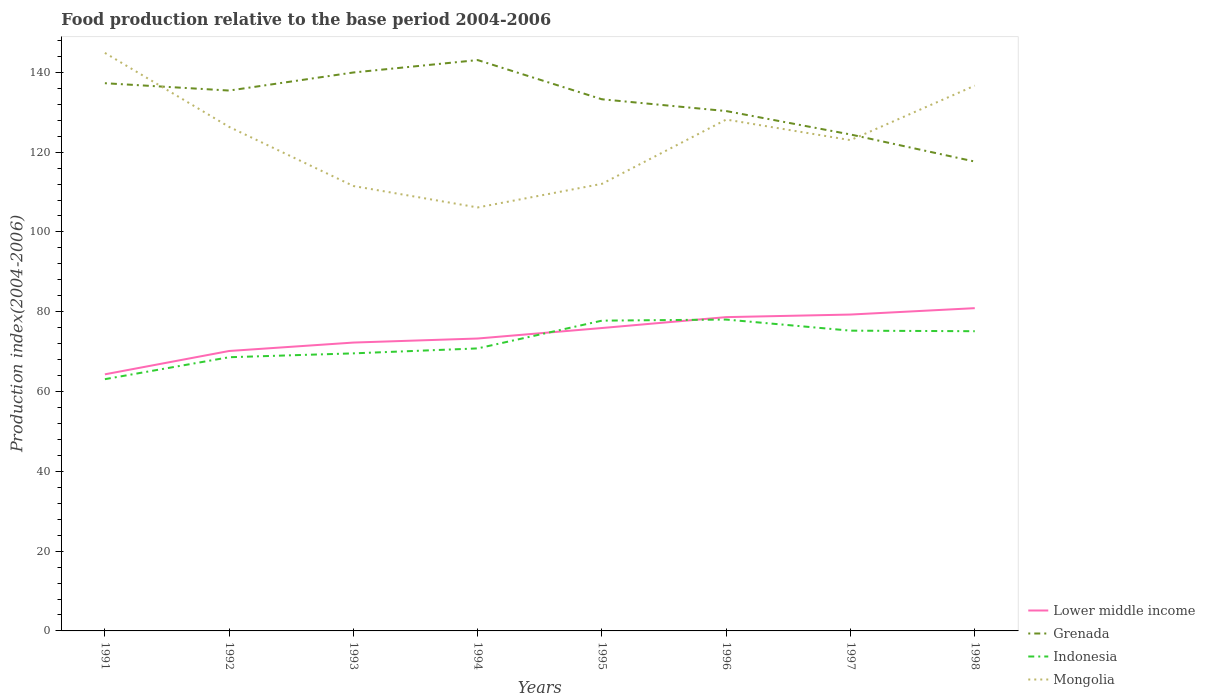Does the line corresponding to Grenada intersect with the line corresponding to Lower middle income?
Offer a terse response. No. Across all years, what is the maximum food production index in Grenada?
Offer a terse response. 117.64. In which year was the food production index in Mongolia maximum?
Offer a terse response. 1994. What is the total food production index in Indonesia in the graph?
Offer a very short reply. -12.16. What is the difference between the highest and the second highest food production index in Grenada?
Provide a succinct answer. 25.44. How many lines are there?
Keep it short and to the point. 4. How many years are there in the graph?
Your answer should be compact. 8. Are the values on the major ticks of Y-axis written in scientific E-notation?
Keep it short and to the point. No. Does the graph contain any zero values?
Provide a succinct answer. No. Does the graph contain grids?
Provide a succinct answer. No. How many legend labels are there?
Ensure brevity in your answer.  4. How are the legend labels stacked?
Offer a terse response. Vertical. What is the title of the graph?
Offer a terse response. Food production relative to the base period 2004-2006. Does "Lithuania" appear as one of the legend labels in the graph?
Offer a terse response. No. What is the label or title of the X-axis?
Provide a short and direct response. Years. What is the label or title of the Y-axis?
Your answer should be very brief. Production index(2004-2006). What is the Production index(2004-2006) of Lower middle income in 1991?
Give a very brief answer. 64.31. What is the Production index(2004-2006) in Grenada in 1991?
Provide a succinct answer. 137.28. What is the Production index(2004-2006) in Indonesia in 1991?
Ensure brevity in your answer.  63.1. What is the Production index(2004-2006) of Mongolia in 1991?
Make the answer very short. 144.88. What is the Production index(2004-2006) in Lower middle income in 1992?
Make the answer very short. 70.16. What is the Production index(2004-2006) in Grenada in 1992?
Make the answer very short. 135.44. What is the Production index(2004-2006) of Indonesia in 1992?
Give a very brief answer. 68.6. What is the Production index(2004-2006) in Mongolia in 1992?
Your answer should be compact. 126.33. What is the Production index(2004-2006) in Lower middle income in 1993?
Provide a short and direct response. 72.27. What is the Production index(2004-2006) of Grenada in 1993?
Your answer should be compact. 139.97. What is the Production index(2004-2006) in Indonesia in 1993?
Give a very brief answer. 69.57. What is the Production index(2004-2006) in Mongolia in 1993?
Keep it short and to the point. 111.51. What is the Production index(2004-2006) in Lower middle income in 1994?
Keep it short and to the point. 73.29. What is the Production index(2004-2006) in Grenada in 1994?
Your answer should be very brief. 143.08. What is the Production index(2004-2006) of Indonesia in 1994?
Offer a terse response. 70.81. What is the Production index(2004-2006) in Mongolia in 1994?
Provide a succinct answer. 106.14. What is the Production index(2004-2006) in Lower middle income in 1995?
Your response must be concise. 75.92. What is the Production index(2004-2006) in Grenada in 1995?
Give a very brief answer. 133.25. What is the Production index(2004-2006) in Indonesia in 1995?
Your answer should be very brief. 77.77. What is the Production index(2004-2006) of Mongolia in 1995?
Make the answer very short. 112.06. What is the Production index(2004-2006) of Lower middle income in 1996?
Offer a very short reply. 78.65. What is the Production index(2004-2006) of Grenada in 1996?
Provide a succinct answer. 130.3. What is the Production index(2004-2006) of Indonesia in 1996?
Your response must be concise. 78.04. What is the Production index(2004-2006) of Mongolia in 1996?
Your answer should be very brief. 128.17. What is the Production index(2004-2006) of Lower middle income in 1997?
Give a very brief answer. 79.3. What is the Production index(2004-2006) in Grenada in 1997?
Give a very brief answer. 124.43. What is the Production index(2004-2006) of Indonesia in 1997?
Your response must be concise. 75.26. What is the Production index(2004-2006) of Mongolia in 1997?
Offer a terse response. 123.01. What is the Production index(2004-2006) of Lower middle income in 1998?
Keep it short and to the point. 80.9. What is the Production index(2004-2006) of Grenada in 1998?
Make the answer very short. 117.64. What is the Production index(2004-2006) in Indonesia in 1998?
Give a very brief answer. 75.12. What is the Production index(2004-2006) of Mongolia in 1998?
Your response must be concise. 136.67. Across all years, what is the maximum Production index(2004-2006) of Lower middle income?
Give a very brief answer. 80.9. Across all years, what is the maximum Production index(2004-2006) in Grenada?
Keep it short and to the point. 143.08. Across all years, what is the maximum Production index(2004-2006) of Indonesia?
Offer a very short reply. 78.04. Across all years, what is the maximum Production index(2004-2006) in Mongolia?
Provide a short and direct response. 144.88. Across all years, what is the minimum Production index(2004-2006) of Lower middle income?
Give a very brief answer. 64.31. Across all years, what is the minimum Production index(2004-2006) in Grenada?
Your answer should be compact. 117.64. Across all years, what is the minimum Production index(2004-2006) of Indonesia?
Make the answer very short. 63.1. Across all years, what is the minimum Production index(2004-2006) in Mongolia?
Your answer should be compact. 106.14. What is the total Production index(2004-2006) in Lower middle income in the graph?
Offer a terse response. 594.81. What is the total Production index(2004-2006) of Grenada in the graph?
Make the answer very short. 1061.39. What is the total Production index(2004-2006) in Indonesia in the graph?
Ensure brevity in your answer.  578.27. What is the total Production index(2004-2006) in Mongolia in the graph?
Your answer should be compact. 988.77. What is the difference between the Production index(2004-2006) in Lower middle income in 1991 and that in 1992?
Your answer should be very brief. -5.85. What is the difference between the Production index(2004-2006) of Grenada in 1991 and that in 1992?
Give a very brief answer. 1.84. What is the difference between the Production index(2004-2006) of Mongolia in 1991 and that in 1992?
Provide a succinct answer. 18.55. What is the difference between the Production index(2004-2006) of Lower middle income in 1991 and that in 1993?
Keep it short and to the point. -7.96. What is the difference between the Production index(2004-2006) of Grenada in 1991 and that in 1993?
Your answer should be compact. -2.69. What is the difference between the Production index(2004-2006) of Indonesia in 1991 and that in 1993?
Offer a terse response. -6.47. What is the difference between the Production index(2004-2006) in Mongolia in 1991 and that in 1993?
Offer a terse response. 33.37. What is the difference between the Production index(2004-2006) of Lower middle income in 1991 and that in 1994?
Provide a succinct answer. -8.98. What is the difference between the Production index(2004-2006) in Grenada in 1991 and that in 1994?
Offer a very short reply. -5.8. What is the difference between the Production index(2004-2006) in Indonesia in 1991 and that in 1994?
Give a very brief answer. -7.71. What is the difference between the Production index(2004-2006) of Mongolia in 1991 and that in 1994?
Make the answer very short. 38.74. What is the difference between the Production index(2004-2006) in Lower middle income in 1991 and that in 1995?
Provide a short and direct response. -11.61. What is the difference between the Production index(2004-2006) of Grenada in 1991 and that in 1995?
Offer a very short reply. 4.03. What is the difference between the Production index(2004-2006) of Indonesia in 1991 and that in 1995?
Make the answer very short. -14.67. What is the difference between the Production index(2004-2006) of Mongolia in 1991 and that in 1995?
Make the answer very short. 32.82. What is the difference between the Production index(2004-2006) in Lower middle income in 1991 and that in 1996?
Provide a succinct answer. -14.34. What is the difference between the Production index(2004-2006) of Grenada in 1991 and that in 1996?
Ensure brevity in your answer.  6.98. What is the difference between the Production index(2004-2006) in Indonesia in 1991 and that in 1996?
Ensure brevity in your answer.  -14.94. What is the difference between the Production index(2004-2006) in Mongolia in 1991 and that in 1996?
Make the answer very short. 16.71. What is the difference between the Production index(2004-2006) in Lower middle income in 1991 and that in 1997?
Offer a very short reply. -14.98. What is the difference between the Production index(2004-2006) in Grenada in 1991 and that in 1997?
Your answer should be very brief. 12.85. What is the difference between the Production index(2004-2006) of Indonesia in 1991 and that in 1997?
Your answer should be very brief. -12.16. What is the difference between the Production index(2004-2006) in Mongolia in 1991 and that in 1997?
Your response must be concise. 21.87. What is the difference between the Production index(2004-2006) in Lower middle income in 1991 and that in 1998?
Offer a terse response. -16.58. What is the difference between the Production index(2004-2006) in Grenada in 1991 and that in 1998?
Provide a short and direct response. 19.64. What is the difference between the Production index(2004-2006) in Indonesia in 1991 and that in 1998?
Offer a terse response. -12.02. What is the difference between the Production index(2004-2006) of Mongolia in 1991 and that in 1998?
Make the answer very short. 8.21. What is the difference between the Production index(2004-2006) of Lower middle income in 1992 and that in 1993?
Ensure brevity in your answer.  -2.11. What is the difference between the Production index(2004-2006) in Grenada in 1992 and that in 1993?
Your response must be concise. -4.53. What is the difference between the Production index(2004-2006) in Indonesia in 1992 and that in 1993?
Your answer should be very brief. -0.97. What is the difference between the Production index(2004-2006) of Mongolia in 1992 and that in 1993?
Keep it short and to the point. 14.82. What is the difference between the Production index(2004-2006) in Lower middle income in 1992 and that in 1994?
Your response must be concise. -3.13. What is the difference between the Production index(2004-2006) of Grenada in 1992 and that in 1994?
Your answer should be very brief. -7.64. What is the difference between the Production index(2004-2006) in Indonesia in 1992 and that in 1994?
Your answer should be compact. -2.21. What is the difference between the Production index(2004-2006) in Mongolia in 1992 and that in 1994?
Offer a very short reply. 20.19. What is the difference between the Production index(2004-2006) in Lower middle income in 1992 and that in 1995?
Make the answer very short. -5.76. What is the difference between the Production index(2004-2006) of Grenada in 1992 and that in 1995?
Make the answer very short. 2.19. What is the difference between the Production index(2004-2006) in Indonesia in 1992 and that in 1995?
Provide a short and direct response. -9.17. What is the difference between the Production index(2004-2006) of Mongolia in 1992 and that in 1995?
Offer a very short reply. 14.27. What is the difference between the Production index(2004-2006) of Lower middle income in 1992 and that in 1996?
Your answer should be very brief. -8.49. What is the difference between the Production index(2004-2006) in Grenada in 1992 and that in 1996?
Ensure brevity in your answer.  5.14. What is the difference between the Production index(2004-2006) of Indonesia in 1992 and that in 1996?
Offer a very short reply. -9.44. What is the difference between the Production index(2004-2006) of Mongolia in 1992 and that in 1996?
Provide a succinct answer. -1.84. What is the difference between the Production index(2004-2006) of Lower middle income in 1992 and that in 1997?
Give a very brief answer. -9.13. What is the difference between the Production index(2004-2006) of Grenada in 1992 and that in 1997?
Keep it short and to the point. 11.01. What is the difference between the Production index(2004-2006) in Indonesia in 1992 and that in 1997?
Provide a succinct answer. -6.66. What is the difference between the Production index(2004-2006) in Mongolia in 1992 and that in 1997?
Your answer should be very brief. 3.32. What is the difference between the Production index(2004-2006) in Lower middle income in 1992 and that in 1998?
Ensure brevity in your answer.  -10.73. What is the difference between the Production index(2004-2006) of Grenada in 1992 and that in 1998?
Provide a short and direct response. 17.8. What is the difference between the Production index(2004-2006) in Indonesia in 1992 and that in 1998?
Your answer should be very brief. -6.52. What is the difference between the Production index(2004-2006) of Mongolia in 1992 and that in 1998?
Ensure brevity in your answer.  -10.34. What is the difference between the Production index(2004-2006) in Lower middle income in 1993 and that in 1994?
Keep it short and to the point. -1.02. What is the difference between the Production index(2004-2006) of Grenada in 1993 and that in 1994?
Your answer should be very brief. -3.11. What is the difference between the Production index(2004-2006) in Indonesia in 1993 and that in 1994?
Offer a terse response. -1.24. What is the difference between the Production index(2004-2006) in Mongolia in 1993 and that in 1994?
Give a very brief answer. 5.37. What is the difference between the Production index(2004-2006) of Lower middle income in 1993 and that in 1995?
Offer a terse response. -3.65. What is the difference between the Production index(2004-2006) of Grenada in 1993 and that in 1995?
Make the answer very short. 6.72. What is the difference between the Production index(2004-2006) in Indonesia in 1993 and that in 1995?
Give a very brief answer. -8.2. What is the difference between the Production index(2004-2006) in Mongolia in 1993 and that in 1995?
Keep it short and to the point. -0.55. What is the difference between the Production index(2004-2006) in Lower middle income in 1993 and that in 1996?
Give a very brief answer. -6.38. What is the difference between the Production index(2004-2006) of Grenada in 1993 and that in 1996?
Make the answer very short. 9.67. What is the difference between the Production index(2004-2006) in Indonesia in 1993 and that in 1996?
Offer a terse response. -8.47. What is the difference between the Production index(2004-2006) of Mongolia in 1993 and that in 1996?
Give a very brief answer. -16.66. What is the difference between the Production index(2004-2006) in Lower middle income in 1993 and that in 1997?
Keep it short and to the point. -7.02. What is the difference between the Production index(2004-2006) in Grenada in 1993 and that in 1997?
Your response must be concise. 15.54. What is the difference between the Production index(2004-2006) in Indonesia in 1993 and that in 1997?
Make the answer very short. -5.69. What is the difference between the Production index(2004-2006) of Mongolia in 1993 and that in 1997?
Your response must be concise. -11.5. What is the difference between the Production index(2004-2006) of Lower middle income in 1993 and that in 1998?
Your answer should be very brief. -8.62. What is the difference between the Production index(2004-2006) of Grenada in 1993 and that in 1998?
Keep it short and to the point. 22.33. What is the difference between the Production index(2004-2006) of Indonesia in 1993 and that in 1998?
Provide a short and direct response. -5.55. What is the difference between the Production index(2004-2006) in Mongolia in 1993 and that in 1998?
Your response must be concise. -25.16. What is the difference between the Production index(2004-2006) of Lower middle income in 1994 and that in 1995?
Offer a terse response. -2.63. What is the difference between the Production index(2004-2006) of Grenada in 1994 and that in 1995?
Your response must be concise. 9.83. What is the difference between the Production index(2004-2006) in Indonesia in 1994 and that in 1995?
Offer a very short reply. -6.96. What is the difference between the Production index(2004-2006) of Mongolia in 1994 and that in 1995?
Keep it short and to the point. -5.92. What is the difference between the Production index(2004-2006) of Lower middle income in 1994 and that in 1996?
Provide a succinct answer. -5.36. What is the difference between the Production index(2004-2006) of Grenada in 1994 and that in 1996?
Keep it short and to the point. 12.78. What is the difference between the Production index(2004-2006) of Indonesia in 1994 and that in 1996?
Provide a succinct answer. -7.23. What is the difference between the Production index(2004-2006) in Mongolia in 1994 and that in 1996?
Provide a succinct answer. -22.03. What is the difference between the Production index(2004-2006) in Lower middle income in 1994 and that in 1997?
Provide a succinct answer. -6.01. What is the difference between the Production index(2004-2006) of Grenada in 1994 and that in 1997?
Provide a succinct answer. 18.65. What is the difference between the Production index(2004-2006) in Indonesia in 1994 and that in 1997?
Provide a short and direct response. -4.45. What is the difference between the Production index(2004-2006) of Mongolia in 1994 and that in 1997?
Ensure brevity in your answer.  -16.87. What is the difference between the Production index(2004-2006) of Lower middle income in 1994 and that in 1998?
Provide a short and direct response. -7.61. What is the difference between the Production index(2004-2006) in Grenada in 1994 and that in 1998?
Keep it short and to the point. 25.44. What is the difference between the Production index(2004-2006) of Indonesia in 1994 and that in 1998?
Provide a succinct answer. -4.31. What is the difference between the Production index(2004-2006) of Mongolia in 1994 and that in 1998?
Ensure brevity in your answer.  -30.53. What is the difference between the Production index(2004-2006) in Lower middle income in 1995 and that in 1996?
Provide a succinct answer. -2.73. What is the difference between the Production index(2004-2006) in Grenada in 1995 and that in 1996?
Your answer should be very brief. 2.95. What is the difference between the Production index(2004-2006) of Indonesia in 1995 and that in 1996?
Ensure brevity in your answer.  -0.27. What is the difference between the Production index(2004-2006) in Mongolia in 1995 and that in 1996?
Offer a very short reply. -16.11. What is the difference between the Production index(2004-2006) of Lower middle income in 1995 and that in 1997?
Keep it short and to the point. -3.38. What is the difference between the Production index(2004-2006) of Grenada in 1995 and that in 1997?
Make the answer very short. 8.82. What is the difference between the Production index(2004-2006) in Indonesia in 1995 and that in 1997?
Offer a very short reply. 2.51. What is the difference between the Production index(2004-2006) in Mongolia in 1995 and that in 1997?
Provide a succinct answer. -10.95. What is the difference between the Production index(2004-2006) of Lower middle income in 1995 and that in 1998?
Give a very brief answer. -4.98. What is the difference between the Production index(2004-2006) in Grenada in 1995 and that in 1998?
Provide a short and direct response. 15.61. What is the difference between the Production index(2004-2006) of Indonesia in 1995 and that in 1998?
Ensure brevity in your answer.  2.65. What is the difference between the Production index(2004-2006) in Mongolia in 1995 and that in 1998?
Provide a succinct answer. -24.61. What is the difference between the Production index(2004-2006) of Lower middle income in 1996 and that in 1997?
Provide a succinct answer. -0.65. What is the difference between the Production index(2004-2006) in Grenada in 1996 and that in 1997?
Make the answer very short. 5.87. What is the difference between the Production index(2004-2006) of Indonesia in 1996 and that in 1997?
Offer a terse response. 2.78. What is the difference between the Production index(2004-2006) of Mongolia in 1996 and that in 1997?
Offer a terse response. 5.16. What is the difference between the Production index(2004-2006) of Lower middle income in 1996 and that in 1998?
Provide a succinct answer. -2.25. What is the difference between the Production index(2004-2006) in Grenada in 1996 and that in 1998?
Offer a very short reply. 12.66. What is the difference between the Production index(2004-2006) in Indonesia in 1996 and that in 1998?
Make the answer very short. 2.92. What is the difference between the Production index(2004-2006) in Lower middle income in 1997 and that in 1998?
Give a very brief answer. -1.6. What is the difference between the Production index(2004-2006) in Grenada in 1997 and that in 1998?
Offer a very short reply. 6.79. What is the difference between the Production index(2004-2006) of Indonesia in 1997 and that in 1998?
Offer a very short reply. 0.14. What is the difference between the Production index(2004-2006) in Mongolia in 1997 and that in 1998?
Offer a very short reply. -13.66. What is the difference between the Production index(2004-2006) in Lower middle income in 1991 and the Production index(2004-2006) in Grenada in 1992?
Keep it short and to the point. -71.13. What is the difference between the Production index(2004-2006) of Lower middle income in 1991 and the Production index(2004-2006) of Indonesia in 1992?
Your response must be concise. -4.29. What is the difference between the Production index(2004-2006) in Lower middle income in 1991 and the Production index(2004-2006) in Mongolia in 1992?
Keep it short and to the point. -62.02. What is the difference between the Production index(2004-2006) in Grenada in 1991 and the Production index(2004-2006) in Indonesia in 1992?
Offer a terse response. 68.68. What is the difference between the Production index(2004-2006) in Grenada in 1991 and the Production index(2004-2006) in Mongolia in 1992?
Provide a succinct answer. 10.95. What is the difference between the Production index(2004-2006) in Indonesia in 1991 and the Production index(2004-2006) in Mongolia in 1992?
Give a very brief answer. -63.23. What is the difference between the Production index(2004-2006) in Lower middle income in 1991 and the Production index(2004-2006) in Grenada in 1993?
Provide a short and direct response. -75.66. What is the difference between the Production index(2004-2006) of Lower middle income in 1991 and the Production index(2004-2006) of Indonesia in 1993?
Keep it short and to the point. -5.26. What is the difference between the Production index(2004-2006) in Lower middle income in 1991 and the Production index(2004-2006) in Mongolia in 1993?
Your response must be concise. -47.2. What is the difference between the Production index(2004-2006) in Grenada in 1991 and the Production index(2004-2006) in Indonesia in 1993?
Give a very brief answer. 67.71. What is the difference between the Production index(2004-2006) in Grenada in 1991 and the Production index(2004-2006) in Mongolia in 1993?
Your answer should be very brief. 25.77. What is the difference between the Production index(2004-2006) in Indonesia in 1991 and the Production index(2004-2006) in Mongolia in 1993?
Your response must be concise. -48.41. What is the difference between the Production index(2004-2006) of Lower middle income in 1991 and the Production index(2004-2006) of Grenada in 1994?
Give a very brief answer. -78.77. What is the difference between the Production index(2004-2006) of Lower middle income in 1991 and the Production index(2004-2006) of Indonesia in 1994?
Make the answer very short. -6.5. What is the difference between the Production index(2004-2006) in Lower middle income in 1991 and the Production index(2004-2006) in Mongolia in 1994?
Your answer should be compact. -41.83. What is the difference between the Production index(2004-2006) in Grenada in 1991 and the Production index(2004-2006) in Indonesia in 1994?
Offer a terse response. 66.47. What is the difference between the Production index(2004-2006) in Grenada in 1991 and the Production index(2004-2006) in Mongolia in 1994?
Make the answer very short. 31.14. What is the difference between the Production index(2004-2006) in Indonesia in 1991 and the Production index(2004-2006) in Mongolia in 1994?
Your answer should be very brief. -43.04. What is the difference between the Production index(2004-2006) in Lower middle income in 1991 and the Production index(2004-2006) in Grenada in 1995?
Make the answer very short. -68.94. What is the difference between the Production index(2004-2006) in Lower middle income in 1991 and the Production index(2004-2006) in Indonesia in 1995?
Your answer should be very brief. -13.46. What is the difference between the Production index(2004-2006) in Lower middle income in 1991 and the Production index(2004-2006) in Mongolia in 1995?
Ensure brevity in your answer.  -47.75. What is the difference between the Production index(2004-2006) in Grenada in 1991 and the Production index(2004-2006) in Indonesia in 1995?
Your answer should be compact. 59.51. What is the difference between the Production index(2004-2006) of Grenada in 1991 and the Production index(2004-2006) of Mongolia in 1995?
Ensure brevity in your answer.  25.22. What is the difference between the Production index(2004-2006) in Indonesia in 1991 and the Production index(2004-2006) in Mongolia in 1995?
Your answer should be very brief. -48.96. What is the difference between the Production index(2004-2006) of Lower middle income in 1991 and the Production index(2004-2006) of Grenada in 1996?
Provide a succinct answer. -65.99. What is the difference between the Production index(2004-2006) of Lower middle income in 1991 and the Production index(2004-2006) of Indonesia in 1996?
Provide a succinct answer. -13.73. What is the difference between the Production index(2004-2006) in Lower middle income in 1991 and the Production index(2004-2006) in Mongolia in 1996?
Your answer should be compact. -63.86. What is the difference between the Production index(2004-2006) in Grenada in 1991 and the Production index(2004-2006) in Indonesia in 1996?
Give a very brief answer. 59.24. What is the difference between the Production index(2004-2006) in Grenada in 1991 and the Production index(2004-2006) in Mongolia in 1996?
Your response must be concise. 9.11. What is the difference between the Production index(2004-2006) in Indonesia in 1991 and the Production index(2004-2006) in Mongolia in 1996?
Your response must be concise. -65.07. What is the difference between the Production index(2004-2006) of Lower middle income in 1991 and the Production index(2004-2006) of Grenada in 1997?
Offer a very short reply. -60.12. What is the difference between the Production index(2004-2006) of Lower middle income in 1991 and the Production index(2004-2006) of Indonesia in 1997?
Ensure brevity in your answer.  -10.95. What is the difference between the Production index(2004-2006) in Lower middle income in 1991 and the Production index(2004-2006) in Mongolia in 1997?
Ensure brevity in your answer.  -58.7. What is the difference between the Production index(2004-2006) of Grenada in 1991 and the Production index(2004-2006) of Indonesia in 1997?
Provide a short and direct response. 62.02. What is the difference between the Production index(2004-2006) in Grenada in 1991 and the Production index(2004-2006) in Mongolia in 1997?
Your answer should be compact. 14.27. What is the difference between the Production index(2004-2006) in Indonesia in 1991 and the Production index(2004-2006) in Mongolia in 1997?
Give a very brief answer. -59.91. What is the difference between the Production index(2004-2006) of Lower middle income in 1991 and the Production index(2004-2006) of Grenada in 1998?
Give a very brief answer. -53.33. What is the difference between the Production index(2004-2006) in Lower middle income in 1991 and the Production index(2004-2006) in Indonesia in 1998?
Make the answer very short. -10.81. What is the difference between the Production index(2004-2006) in Lower middle income in 1991 and the Production index(2004-2006) in Mongolia in 1998?
Offer a very short reply. -72.36. What is the difference between the Production index(2004-2006) of Grenada in 1991 and the Production index(2004-2006) of Indonesia in 1998?
Your answer should be compact. 62.16. What is the difference between the Production index(2004-2006) of Grenada in 1991 and the Production index(2004-2006) of Mongolia in 1998?
Give a very brief answer. 0.61. What is the difference between the Production index(2004-2006) of Indonesia in 1991 and the Production index(2004-2006) of Mongolia in 1998?
Provide a succinct answer. -73.57. What is the difference between the Production index(2004-2006) of Lower middle income in 1992 and the Production index(2004-2006) of Grenada in 1993?
Offer a very short reply. -69.81. What is the difference between the Production index(2004-2006) in Lower middle income in 1992 and the Production index(2004-2006) in Indonesia in 1993?
Offer a terse response. 0.59. What is the difference between the Production index(2004-2006) of Lower middle income in 1992 and the Production index(2004-2006) of Mongolia in 1993?
Your response must be concise. -41.35. What is the difference between the Production index(2004-2006) of Grenada in 1992 and the Production index(2004-2006) of Indonesia in 1993?
Offer a very short reply. 65.87. What is the difference between the Production index(2004-2006) in Grenada in 1992 and the Production index(2004-2006) in Mongolia in 1993?
Make the answer very short. 23.93. What is the difference between the Production index(2004-2006) in Indonesia in 1992 and the Production index(2004-2006) in Mongolia in 1993?
Give a very brief answer. -42.91. What is the difference between the Production index(2004-2006) of Lower middle income in 1992 and the Production index(2004-2006) of Grenada in 1994?
Provide a succinct answer. -72.92. What is the difference between the Production index(2004-2006) in Lower middle income in 1992 and the Production index(2004-2006) in Indonesia in 1994?
Provide a short and direct response. -0.65. What is the difference between the Production index(2004-2006) in Lower middle income in 1992 and the Production index(2004-2006) in Mongolia in 1994?
Offer a terse response. -35.98. What is the difference between the Production index(2004-2006) of Grenada in 1992 and the Production index(2004-2006) of Indonesia in 1994?
Provide a succinct answer. 64.63. What is the difference between the Production index(2004-2006) of Grenada in 1992 and the Production index(2004-2006) of Mongolia in 1994?
Ensure brevity in your answer.  29.3. What is the difference between the Production index(2004-2006) in Indonesia in 1992 and the Production index(2004-2006) in Mongolia in 1994?
Ensure brevity in your answer.  -37.54. What is the difference between the Production index(2004-2006) of Lower middle income in 1992 and the Production index(2004-2006) of Grenada in 1995?
Your answer should be compact. -63.09. What is the difference between the Production index(2004-2006) of Lower middle income in 1992 and the Production index(2004-2006) of Indonesia in 1995?
Ensure brevity in your answer.  -7.61. What is the difference between the Production index(2004-2006) of Lower middle income in 1992 and the Production index(2004-2006) of Mongolia in 1995?
Make the answer very short. -41.9. What is the difference between the Production index(2004-2006) of Grenada in 1992 and the Production index(2004-2006) of Indonesia in 1995?
Offer a terse response. 57.67. What is the difference between the Production index(2004-2006) of Grenada in 1992 and the Production index(2004-2006) of Mongolia in 1995?
Offer a terse response. 23.38. What is the difference between the Production index(2004-2006) of Indonesia in 1992 and the Production index(2004-2006) of Mongolia in 1995?
Make the answer very short. -43.46. What is the difference between the Production index(2004-2006) of Lower middle income in 1992 and the Production index(2004-2006) of Grenada in 1996?
Your answer should be very brief. -60.14. What is the difference between the Production index(2004-2006) of Lower middle income in 1992 and the Production index(2004-2006) of Indonesia in 1996?
Keep it short and to the point. -7.88. What is the difference between the Production index(2004-2006) of Lower middle income in 1992 and the Production index(2004-2006) of Mongolia in 1996?
Your answer should be compact. -58.01. What is the difference between the Production index(2004-2006) of Grenada in 1992 and the Production index(2004-2006) of Indonesia in 1996?
Your response must be concise. 57.4. What is the difference between the Production index(2004-2006) of Grenada in 1992 and the Production index(2004-2006) of Mongolia in 1996?
Keep it short and to the point. 7.27. What is the difference between the Production index(2004-2006) of Indonesia in 1992 and the Production index(2004-2006) of Mongolia in 1996?
Ensure brevity in your answer.  -59.57. What is the difference between the Production index(2004-2006) in Lower middle income in 1992 and the Production index(2004-2006) in Grenada in 1997?
Offer a terse response. -54.27. What is the difference between the Production index(2004-2006) of Lower middle income in 1992 and the Production index(2004-2006) of Indonesia in 1997?
Make the answer very short. -5.1. What is the difference between the Production index(2004-2006) in Lower middle income in 1992 and the Production index(2004-2006) in Mongolia in 1997?
Offer a very short reply. -52.85. What is the difference between the Production index(2004-2006) of Grenada in 1992 and the Production index(2004-2006) of Indonesia in 1997?
Offer a terse response. 60.18. What is the difference between the Production index(2004-2006) of Grenada in 1992 and the Production index(2004-2006) of Mongolia in 1997?
Make the answer very short. 12.43. What is the difference between the Production index(2004-2006) of Indonesia in 1992 and the Production index(2004-2006) of Mongolia in 1997?
Provide a short and direct response. -54.41. What is the difference between the Production index(2004-2006) in Lower middle income in 1992 and the Production index(2004-2006) in Grenada in 1998?
Keep it short and to the point. -47.48. What is the difference between the Production index(2004-2006) of Lower middle income in 1992 and the Production index(2004-2006) of Indonesia in 1998?
Keep it short and to the point. -4.96. What is the difference between the Production index(2004-2006) in Lower middle income in 1992 and the Production index(2004-2006) in Mongolia in 1998?
Offer a very short reply. -66.51. What is the difference between the Production index(2004-2006) of Grenada in 1992 and the Production index(2004-2006) of Indonesia in 1998?
Your answer should be compact. 60.32. What is the difference between the Production index(2004-2006) in Grenada in 1992 and the Production index(2004-2006) in Mongolia in 1998?
Your answer should be compact. -1.23. What is the difference between the Production index(2004-2006) in Indonesia in 1992 and the Production index(2004-2006) in Mongolia in 1998?
Make the answer very short. -68.07. What is the difference between the Production index(2004-2006) of Lower middle income in 1993 and the Production index(2004-2006) of Grenada in 1994?
Your response must be concise. -70.81. What is the difference between the Production index(2004-2006) of Lower middle income in 1993 and the Production index(2004-2006) of Indonesia in 1994?
Offer a terse response. 1.46. What is the difference between the Production index(2004-2006) of Lower middle income in 1993 and the Production index(2004-2006) of Mongolia in 1994?
Offer a very short reply. -33.87. What is the difference between the Production index(2004-2006) in Grenada in 1993 and the Production index(2004-2006) in Indonesia in 1994?
Offer a very short reply. 69.16. What is the difference between the Production index(2004-2006) in Grenada in 1993 and the Production index(2004-2006) in Mongolia in 1994?
Your answer should be very brief. 33.83. What is the difference between the Production index(2004-2006) of Indonesia in 1993 and the Production index(2004-2006) of Mongolia in 1994?
Provide a short and direct response. -36.57. What is the difference between the Production index(2004-2006) of Lower middle income in 1993 and the Production index(2004-2006) of Grenada in 1995?
Provide a succinct answer. -60.98. What is the difference between the Production index(2004-2006) of Lower middle income in 1993 and the Production index(2004-2006) of Indonesia in 1995?
Your answer should be compact. -5.5. What is the difference between the Production index(2004-2006) of Lower middle income in 1993 and the Production index(2004-2006) of Mongolia in 1995?
Provide a short and direct response. -39.79. What is the difference between the Production index(2004-2006) in Grenada in 1993 and the Production index(2004-2006) in Indonesia in 1995?
Ensure brevity in your answer.  62.2. What is the difference between the Production index(2004-2006) of Grenada in 1993 and the Production index(2004-2006) of Mongolia in 1995?
Provide a succinct answer. 27.91. What is the difference between the Production index(2004-2006) of Indonesia in 1993 and the Production index(2004-2006) of Mongolia in 1995?
Make the answer very short. -42.49. What is the difference between the Production index(2004-2006) of Lower middle income in 1993 and the Production index(2004-2006) of Grenada in 1996?
Your answer should be very brief. -58.03. What is the difference between the Production index(2004-2006) of Lower middle income in 1993 and the Production index(2004-2006) of Indonesia in 1996?
Make the answer very short. -5.77. What is the difference between the Production index(2004-2006) in Lower middle income in 1993 and the Production index(2004-2006) in Mongolia in 1996?
Provide a short and direct response. -55.9. What is the difference between the Production index(2004-2006) in Grenada in 1993 and the Production index(2004-2006) in Indonesia in 1996?
Offer a terse response. 61.93. What is the difference between the Production index(2004-2006) of Grenada in 1993 and the Production index(2004-2006) of Mongolia in 1996?
Provide a succinct answer. 11.8. What is the difference between the Production index(2004-2006) of Indonesia in 1993 and the Production index(2004-2006) of Mongolia in 1996?
Ensure brevity in your answer.  -58.6. What is the difference between the Production index(2004-2006) in Lower middle income in 1993 and the Production index(2004-2006) in Grenada in 1997?
Provide a short and direct response. -52.16. What is the difference between the Production index(2004-2006) of Lower middle income in 1993 and the Production index(2004-2006) of Indonesia in 1997?
Your response must be concise. -2.99. What is the difference between the Production index(2004-2006) in Lower middle income in 1993 and the Production index(2004-2006) in Mongolia in 1997?
Keep it short and to the point. -50.74. What is the difference between the Production index(2004-2006) of Grenada in 1993 and the Production index(2004-2006) of Indonesia in 1997?
Your answer should be compact. 64.71. What is the difference between the Production index(2004-2006) in Grenada in 1993 and the Production index(2004-2006) in Mongolia in 1997?
Keep it short and to the point. 16.96. What is the difference between the Production index(2004-2006) in Indonesia in 1993 and the Production index(2004-2006) in Mongolia in 1997?
Offer a terse response. -53.44. What is the difference between the Production index(2004-2006) of Lower middle income in 1993 and the Production index(2004-2006) of Grenada in 1998?
Offer a terse response. -45.37. What is the difference between the Production index(2004-2006) of Lower middle income in 1993 and the Production index(2004-2006) of Indonesia in 1998?
Offer a terse response. -2.85. What is the difference between the Production index(2004-2006) of Lower middle income in 1993 and the Production index(2004-2006) of Mongolia in 1998?
Ensure brevity in your answer.  -64.4. What is the difference between the Production index(2004-2006) in Grenada in 1993 and the Production index(2004-2006) in Indonesia in 1998?
Offer a terse response. 64.85. What is the difference between the Production index(2004-2006) of Indonesia in 1993 and the Production index(2004-2006) of Mongolia in 1998?
Offer a terse response. -67.1. What is the difference between the Production index(2004-2006) in Lower middle income in 1994 and the Production index(2004-2006) in Grenada in 1995?
Ensure brevity in your answer.  -59.96. What is the difference between the Production index(2004-2006) of Lower middle income in 1994 and the Production index(2004-2006) of Indonesia in 1995?
Provide a succinct answer. -4.48. What is the difference between the Production index(2004-2006) in Lower middle income in 1994 and the Production index(2004-2006) in Mongolia in 1995?
Give a very brief answer. -38.77. What is the difference between the Production index(2004-2006) in Grenada in 1994 and the Production index(2004-2006) in Indonesia in 1995?
Give a very brief answer. 65.31. What is the difference between the Production index(2004-2006) of Grenada in 1994 and the Production index(2004-2006) of Mongolia in 1995?
Keep it short and to the point. 31.02. What is the difference between the Production index(2004-2006) in Indonesia in 1994 and the Production index(2004-2006) in Mongolia in 1995?
Provide a short and direct response. -41.25. What is the difference between the Production index(2004-2006) of Lower middle income in 1994 and the Production index(2004-2006) of Grenada in 1996?
Offer a terse response. -57.01. What is the difference between the Production index(2004-2006) of Lower middle income in 1994 and the Production index(2004-2006) of Indonesia in 1996?
Offer a terse response. -4.75. What is the difference between the Production index(2004-2006) in Lower middle income in 1994 and the Production index(2004-2006) in Mongolia in 1996?
Your response must be concise. -54.88. What is the difference between the Production index(2004-2006) of Grenada in 1994 and the Production index(2004-2006) of Indonesia in 1996?
Provide a succinct answer. 65.04. What is the difference between the Production index(2004-2006) in Grenada in 1994 and the Production index(2004-2006) in Mongolia in 1996?
Offer a terse response. 14.91. What is the difference between the Production index(2004-2006) in Indonesia in 1994 and the Production index(2004-2006) in Mongolia in 1996?
Keep it short and to the point. -57.36. What is the difference between the Production index(2004-2006) in Lower middle income in 1994 and the Production index(2004-2006) in Grenada in 1997?
Your response must be concise. -51.14. What is the difference between the Production index(2004-2006) in Lower middle income in 1994 and the Production index(2004-2006) in Indonesia in 1997?
Keep it short and to the point. -1.97. What is the difference between the Production index(2004-2006) of Lower middle income in 1994 and the Production index(2004-2006) of Mongolia in 1997?
Your response must be concise. -49.72. What is the difference between the Production index(2004-2006) in Grenada in 1994 and the Production index(2004-2006) in Indonesia in 1997?
Ensure brevity in your answer.  67.82. What is the difference between the Production index(2004-2006) in Grenada in 1994 and the Production index(2004-2006) in Mongolia in 1997?
Your answer should be compact. 20.07. What is the difference between the Production index(2004-2006) of Indonesia in 1994 and the Production index(2004-2006) of Mongolia in 1997?
Make the answer very short. -52.2. What is the difference between the Production index(2004-2006) of Lower middle income in 1994 and the Production index(2004-2006) of Grenada in 1998?
Provide a succinct answer. -44.35. What is the difference between the Production index(2004-2006) of Lower middle income in 1994 and the Production index(2004-2006) of Indonesia in 1998?
Make the answer very short. -1.83. What is the difference between the Production index(2004-2006) in Lower middle income in 1994 and the Production index(2004-2006) in Mongolia in 1998?
Your answer should be very brief. -63.38. What is the difference between the Production index(2004-2006) of Grenada in 1994 and the Production index(2004-2006) of Indonesia in 1998?
Your answer should be compact. 67.96. What is the difference between the Production index(2004-2006) in Grenada in 1994 and the Production index(2004-2006) in Mongolia in 1998?
Your answer should be compact. 6.41. What is the difference between the Production index(2004-2006) of Indonesia in 1994 and the Production index(2004-2006) of Mongolia in 1998?
Keep it short and to the point. -65.86. What is the difference between the Production index(2004-2006) in Lower middle income in 1995 and the Production index(2004-2006) in Grenada in 1996?
Your answer should be very brief. -54.38. What is the difference between the Production index(2004-2006) in Lower middle income in 1995 and the Production index(2004-2006) in Indonesia in 1996?
Make the answer very short. -2.12. What is the difference between the Production index(2004-2006) of Lower middle income in 1995 and the Production index(2004-2006) of Mongolia in 1996?
Your response must be concise. -52.25. What is the difference between the Production index(2004-2006) of Grenada in 1995 and the Production index(2004-2006) of Indonesia in 1996?
Your answer should be very brief. 55.21. What is the difference between the Production index(2004-2006) of Grenada in 1995 and the Production index(2004-2006) of Mongolia in 1996?
Offer a very short reply. 5.08. What is the difference between the Production index(2004-2006) in Indonesia in 1995 and the Production index(2004-2006) in Mongolia in 1996?
Your answer should be very brief. -50.4. What is the difference between the Production index(2004-2006) in Lower middle income in 1995 and the Production index(2004-2006) in Grenada in 1997?
Your response must be concise. -48.51. What is the difference between the Production index(2004-2006) in Lower middle income in 1995 and the Production index(2004-2006) in Indonesia in 1997?
Provide a succinct answer. 0.66. What is the difference between the Production index(2004-2006) of Lower middle income in 1995 and the Production index(2004-2006) of Mongolia in 1997?
Offer a very short reply. -47.09. What is the difference between the Production index(2004-2006) in Grenada in 1995 and the Production index(2004-2006) in Indonesia in 1997?
Make the answer very short. 57.99. What is the difference between the Production index(2004-2006) in Grenada in 1995 and the Production index(2004-2006) in Mongolia in 1997?
Keep it short and to the point. 10.24. What is the difference between the Production index(2004-2006) in Indonesia in 1995 and the Production index(2004-2006) in Mongolia in 1997?
Your response must be concise. -45.24. What is the difference between the Production index(2004-2006) of Lower middle income in 1995 and the Production index(2004-2006) of Grenada in 1998?
Provide a short and direct response. -41.72. What is the difference between the Production index(2004-2006) in Lower middle income in 1995 and the Production index(2004-2006) in Indonesia in 1998?
Offer a terse response. 0.8. What is the difference between the Production index(2004-2006) in Lower middle income in 1995 and the Production index(2004-2006) in Mongolia in 1998?
Offer a terse response. -60.75. What is the difference between the Production index(2004-2006) in Grenada in 1995 and the Production index(2004-2006) in Indonesia in 1998?
Your answer should be very brief. 58.13. What is the difference between the Production index(2004-2006) of Grenada in 1995 and the Production index(2004-2006) of Mongolia in 1998?
Provide a succinct answer. -3.42. What is the difference between the Production index(2004-2006) in Indonesia in 1995 and the Production index(2004-2006) in Mongolia in 1998?
Provide a short and direct response. -58.9. What is the difference between the Production index(2004-2006) in Lower middle income in 1996 and the Production index(2004-2006) in Grenada in 1997?
Provide a succinct answer. -45.78. What is the difference between the Production index(2004-2006) of Lower middle income in 1996 and the Production index(2004-2006) of Indonesia in 1997?
Your answer should be compact. 3.39. What is the difference between the Production index(2004-2006) in Lower middle income in 1996 and the Production index(2004-2006) in Mongolia in 1997?
Offer a very short reply. -44.36. What is the difference between the Production index(2004-2006) of Grenada in 1996 and the Production index(2004-2006) of Indonesia in 1997?
Your response must be concise. 55.04. What is the difference between the Production index(2004-2006) of Grenada in 1996 and the Production index(2004-2006) of Mongolia in 1997?
Provide a succinct answer. 7.29. What is the difference between the Production index(2004-2006) of Indonesia in 1996 and the Production index(2004-2006) of Mongolia in 1997?
Provide a short and direct response. -44.97. What is the difference between the Production index(2004-2006) of Lower middle income in 1996 and the Production index(2004-2006) of Grenada in 1998?
Keep it short and to the point. -38.99. What is the difference between the Production index(2004-2006) in Lower middle income in 1996 and the Production index(2004-2006) in Indonesia in 1998?
Keep it short and to the point. 3.53. What is the difference between the Production index(2004-2006) in Lower middle income in 1996 and the Production index(2004-2006) in Mongolia in 1998?
Offer a terse response. -58.02. What is the difference between the Production index(2004-2006) of Grenada in 1996 and the Production index(2004-2006) of Indonesia in 1998?
Provide a short and direct response. 55.18. What is the difference between the Production index(2004-2006) of Grenada in 1996 and the Production index(2004-2006) of Mongolia in 1998?
Provide a short and direct response. -6.37. What is the difference between the Production index(2004-2006) in Indonesia in 1996 and the Production index(2004-2006) in Mongolia in 1998?
Your answer should be very brief. -58.63. What is the difference between the Production index(2004-2006) of Lower middle income in 1997 and the Production index(2004-2006) of Grenada in 1998?
Offer a terse response. -38.34. What is the difference between the Production index(2004-2006) in Lower middle income in 1997 and the Production index(2004-2006) in Indonesia in 1998?
Give a very brief answer. 4.18. What is the difference between the Production index(2004-2006) of Lower middle income in 1997 and the Production index(2004-2006) of Mongolia in 1998?
Your response must be concise. -57.37. What is the difference between the Production index(2004-2006) of Grenada in 1997 and the Production index(2004-2006) of Indonesia in 1998?
Keep it short and to the point. 49.31. What is the difference between the Production index(2004-2006) of Grenada in 1997 and the Production index(2004-2006) of Mongolia in 1998?
Ensure brevity in your answer.  -12.24. What is the difference between the Production index(2004-2006) in Indonesia in 1997 and the Production index(2004-2006) in Mongolia in 1998?
Your answer should be compact. -61.41. What is the average Production index(2004-2006) in Lower middle income per year?
Ensure brevity in your answer.  74.35. What is the average Production index(2004-2006) of Grenada per year?
Give a very brief answer. 132.67. What is the average Production index(2004-2006) of Indonesia per year?
Your answer should be very brief. 72.28. What is the average Production index(2004-2006) in Mongolia per year?
Make the answer very short. 123.6. In the year 1991, what is the difference between the Production index(2004-2006) in Lower middle income and Production index(2004-2006) in Grenada?
Give a very brief answer. -72.97. In the year 1991, what is the difference between the Production index(2004-2006) of Lower middle income and Production index(2004-2006) of Indonesia?
Ensure brevity in your answer.  1.21. In the year 1991, what is the difference between the Production index(2004-2006) in Lower middle income and Production index(2004-2006) in Mongolia?
Your response must be concise. -80.57. In the year 1991, what is the difference between the Production index(2004-2006) in Grenada and Production index(2004-2006) in Indonesia?
Provide a succinct answer. 74.18. In the year 1991, what is the difference between the Production index(2004-2006) in Indonesia and Production index(2004-2006) in Mongolia?
Provide a short and direct response. -81.78. In the year 1992, what is the difference between the Production index(2004-2006) of Lower middle income and Production index(2004-2006) of Grenada?
Keep it short and to the point. -65.28. In the year 1992, what is the difference between the Production index(2004-2006) of Lower middle income and Production index(2004-2006) of Indonesia?
Your answer should be compact. 1.56. In the year 1992, what is the difference between the Production index(2004-2006) in Lower middle income and Production index(2004-2006) in Mongolia?
Give a very brief answer. -56.17. In the year 1992, what is the difference between the Production index(2004-2006) in Grenada and Production index(2004-2006) in Indonesia?
Make the answer very short. 66.84. In the year 1992, what is the difference between the Production index(2004-2006) of Grenada and Production index(2004-2006) of Mongolia?
Your answer should be very brief. 9.11. In the year 1992, what is the difference between the Production index(2004-2006) of Indonesia and Production index(2004-2006) of Mongolia?
Ensure brevity in your answer.  -57.73. In the year 1993, what is the difference between the Production index(2004-2006) of Lower middle income and Production index(2004-2006) of Grenada?
Provide a short and direct response. -67.7. In the year 1993, what is the difference between the Production index(2004-2006) in Lower middle income and Production index(2004-2006) in Indonesia?
Your answer should be very brief. 2.7. In the year 1993, what is the difference between the Production index(2004-2006) of Lower middle income and Production index(2004-2006) of Mongolia?
Offer a terse response. -39.24. In the year 1993, what is the difference between the Production index(2004-2006) in Grenada and Production index(2004-2006) in Indonesia?
Offer a terse response. 70.4. In the year 1993, what is the difference between the Production index(2004-2006) of Grenada and Production index(2004-2006) of Mongolia?
Give a very brief answer. 28.46. In the year 1993, what is the difference between the Production index(2004-2006) in Indonesia and Production index(2004-2006) in Mongolia?
Your answer should be very brief. -41.94. In the year 1994, what is the difference between the Production index(2004-2006) in Lower middle income and Production index(2004-2006) in Grenada?
Keep it short and to the point. -69.79. In the year 1994, what is the difference between the Production index(2004-2006) of Lower middle income and Production index(2004-2006) of Indonesia?
Provide a short and direct response. 2.48. In the year 1994, what is the difference between the Production index(2004-2006) of Lower middle income and Production index(2004-2006) of Mongolia?
Your response must be concise. -32.85. In the year 1994, what is the difference between the Production index(2004-2006) of Grenada and Production index(2004-2006) of Indonesia?
Give a very brief answer. 72.27. In the year 1994, what is the difference between the Production index(2004-2006) in Grenada and Production index(2004-2006) in Mongolia?
Provide a succinct answer. 36.94. In the year 1994, what is the difference between the Production index(2004-2006) of Indonesia and Production index(2004-2006) of Mongolia?
Ensure brevity in your answer.  -35.33. In the year 1995, what is the difference between the Production index(2004-2006) of Lower middle income and Production index(2004-2006) of Grenada?
Make the answer very short. -57.33. In the year 1995, what is the difference between the Production index(2004-2006) of Lower middle income and Production index(2004-2006) of Indonesia?
Offer a terse response. -1.85. In the year 1995, what is the difference between the Production index(2004-2006) of Lower middle income and Production index(2004-2006) of Mongolia?
Offer a very short reply. -36.14. In the year 1995, what is the difference between the Production index(2004-2006) in Grenada and Production index(2004-2006) in Indonesia?
Give a very brief answer. 55.48. In the year 1995, what is the difference between the Production index(2004-2006) in Grenada and Production index(2004-2006) in Mongolia?
Ensure brevity in your answer.  21.19. In the year 1995, what is the difference between the Production index(2004-2006) in Indonesia and Production index(2004-2006) in Mongolia?
Offer a very short reply. -34.29. In the year 1996, what is the difference between the Production index(2004-2006) of Lower middle income and Production index(2004-2006) of Grenada?
Ensure brevity in your answer.  -51.65. In the year 1996, what is the difference between the Production index(2004-2006) in Lower middle income and Production index(2004-2006) in Indonesia?
Offer a very short reply. 0.61. In the year 1996, what is the difference between the Production index(2004-2006) of Lower middle income and Production index(2004-2006) of Mongolia?
Offer a very short reply. -49.52. In the year 1996, what is the difference between the Production index(2004-2006) in Grenada and Production index(2004-2006) in Indonesia?
Your answer should be compact. 52.26. In the year 1996, what is the difference between the Production index(2004-2006) of Grenada and Production index(2004-2006) of Mongolia?
Offer a terse response. 2.13. In the year 1996, what is the difference between the Production index(2004-2006) of Indonesia and Production index(2004-2006) of Mongolia?
Your answer should be very brief. -50.13. In the year 1997, what is the difference between the Production index(2004-2006) of Lower middle income and Production index(2004-2006) of Grenada?
Provide a short and direct response. -45.13. In the year 1997, what is the difference between the Production index(2004-2006) of Lower middle income and Production index(2004-2006) of Indonesia?
Offer a terse response. 4.04. In the year 1997, what is the difference between the Production index(2004-2006) in Lower middle income and Production index(2004-2006) in Mongolia?
Make the answer very short. -43.71. In the year 1997, what is the difference between the Production index(2004-2006) in Grenada and Production index(2004-2006) in Indonesia?
Offer a terse response. 49.17. In the year 1997, what is the difference between the Production index(2004-2006) of Grenada and Production index(2004-2006) of Mongolia?
Provide a succinct answer. 1.42. In the year 1997, what is the difference between the Production index(2004-2006) of Indonesia and Production index(2004-2006) of Mongolia?
Provide a succinct answer. -47.75. In the year 1998, what is the difference between the Production index(2004-2006) in Lower middle income and Production index(2004-2006) in Grenada?
Keep it short and to the point. -36.74. In the year 1998, what is the difference between the Production index(2004-2006) of Lower middle income and Production index(2004-2006) of Indonesia?
Your response must be concise. 5.78. In the year 1998, what is the difference between the Production index(2004-2006) in Lower middle income and Production index(2004-2006) in Mongolia?
Provide a short and direct response. -55.77. In the year 1998, what is the difference between the Production index(2004-2006) of Grenada and Production index(2004-2006) of Indonesia?
Make the answer very short. 42.52. In the year 1998, what is the difference between the Production index(2004-2006) in Grenada and Production index(2004-2006) in Mongolia?
Ensure brevity in your answer.  -19.03. In the year 1998, what is the difference between the Production index(2004-2006) in Indonesia and Production index(2004-2006) in Mongolia?
Ensure brevity in your answer.  -61.55. What is the ratio of the Production index(2004-2006) in Lower middle income in 1991 to that in 1992?
Ensure brevity in your answer.  0.92. What is the ratio of the Production index(2004-2006) of Grenada in 1991 to that in 1992?
Ensure brevity in your answer.  1.01. What is the ratio of the Production index(2004-2006) in Indonesia in 1991 to that in 1992?
Your answer should be compact. 0.92. What is the ratio of the Production index(2004-2006) of Mongolia in 1991 to that in 1992?
Offer a very short reply. 1.15. What is the ratio of the Production index(2004-2006) in Lower middle income in 1991 to that in 1993?
Make the answer very short. 0.89. What is the ratio of the Production index(2004-2006) of Grenada in 1991 to that in 1993?
Give a very brief answer. 0.98. What is the ratio of the Production index(2004-2006) in Indonesia in 1991 to that in 1993?
Your response must be concise. 0.91. What is the ratio of the Production index(2004-2006) of Mongolia in 1991 to that in 1993?
Keep it short and to the point. 1.3. What is the ratio of the Production index(2004-2006) in Lower middle income in 1991 to that in 1994?
Your response must be concise. 0.88. What is the ratio of the Production index(2004-2006) of Grenada in 1991 to that in 1994?
Your response must be concise. 0.96. What is the ratio of the Production index(2004-2006) of Indonesia in 1991 to that in 1994?
Give a very brief answer. 0.89. What is the ratio of the Production index(2004-2006) in Mongolia in 1991 to that in 1994?
Make the answer very short. 1.36. What is the ratio of the Production index(2004-2006) in Lower middle income in 1991 to that in 1995?
Your answer should be compact. 0.85. What is the ratio of the Production index(2004-2006) of Grenada in 1991 to that in 1995?
Give a very brief answer. 1.03. What is the ratio of the Production index(2004-2006) in Indonesia in 1991 to that in 1995?
Offer a terse response. 0.81. What is the ratio of the Production index(2004-2006) in Mongolia in 1991 to that in 1995?
Your answer should be compact. 1.29. What is the ratio of the Production index(2004-2006) of Lower middle income in 1991 to that in 1996?
Keep it short and to the point. 0.82. What is the ratio of the Production index(2004-2006) of Grenada in 1991 to that in 1996?
Give a very brief answer. 1.05. What is the ratio of the Production index(2004-2006) in Indonesia in 1991 to that in 1996?
Offer a very short reply. 0.81. What is the ratio of the Production index(2004-2006) of Mongolia in 1991 to that in 1996?
Your response must be concise. 1.13. What is the ratio of the Production index(2004-2006) in Lower middle income in 1991 to that in 1997?
Ensure brevity in your answer.  0.81. What is the ratio of the Production index(2004-2006) of Grenada in 1991 to that in 1997?
Provide a succinct answer. 1.1. What is the ratio of the Production index(2004-2006) in Indonesia in 1991 to that in 1997?
Provide a succinct answer. 0.84. What is the ratio of the Production index(2004-2006) of Mongolia in 1991 to that in 1997?
Ensure brevity in your answer.  1.18. What is the ratio of the Production index(2004-2006) in Lower middle income in 1991 to that in 1998?
Ensure brevity in your answer.  0.8. What is the ratio of the Production index(2004-2006) of Grenada in 1991 to that in 1998?
Your response must be concise. 1.17. What is the ratio of the Production index(2004-2006) in Indonesia in 1991 to that in 1998?
Your response must be concise. 0.84. What is the ratio of the Production index(2004-2006) of Mongolia in 1991 to that in 1998?
Your answer should be compact. 1.06. What is the ratio of the Production index(2004-2006) in Lower middle income in 1992 to that in 1993?
Provide a short and direct response. 0.97. What is the ratio of the Production index(2004-2006) in Grenada in 1992 to that in 1993?
Your answer should be very brief. 0.97. What is the ratio of the Production index(2004-2006) of Indonesia in 1992 to that in 1993?
Ensure brevity in your answer.  0.99. What is the ratio of the Production index(2004-2006) of Mongolia in 1992 to that in 1993?
Your answer should be very brief. 1.13. What is the ratio of the Production index(2004-2006) of Lower middle income in 1992 to that in 1994?
Offer a very short reply. 0.96. What is the ratio of the Production index(2004-2006) of Grenada in 1992 to that in 1994?
Give a very brief answer. 0.95. What is the ratio of the Production index(2004-2006) of Indonesia in 1992 to that in 1994?
Keep it short and to the point. 0.97. What is the ratio of the Production index(2004-2006) of Mongolia in 1992 to that in 1994?
Keep it short and to the point. 1.19. What is the ratio of the Production index(2004-2006) in Lower middle income in 1992 to that in 1995?
Your response must be concise. 0.92. What is the ratio of the Production index(2004-2006) in Grenada in 1992 to that in 1995?
Your answer should be compact. 1.02. What is the ratio of the Production index(2004-2006) in Indonesia in 1992 to that in 1995?
Your answer should be compact. 0.88. What is the ratio of the Production index(2004-2006) in Mongolia in 1992 to that in 1995?
Offer a terse response. 1.13. What is the ratio of the Production index(2004-2006) of Lower middle income in 1992 to that in 1996?
Provide a short and direct response. 0.89. What is the ratio of the Production index(2004-2006) in Grenada in 1992 to that in 1996?
Your response must be concise. 1.04. What is the ratio of the Production index(2004-2006) of Indonesia in 1992 to that in 1996?
Provide a succinct answer. 0.88. What is the ratio of the Production index(2004-2006) in Mongolia in 1992 to that in 1996?
Offer a terse response. 0.99. What is the ratio of the Production index(2004-2006) of Lower middle income in 1992 to that in 1997?
Offer a very short reply. 0.88. What is the ratio of the Production index(2004-2006) of Grenada in 1992 to that in 1997?
Ensure brevity in your answer.  1.09. What is the ratio of the Production index(2004-2006) in Indonesia in 1992 to that in 1997?
Make the answer very short. 0.91. What is the ratio of the Production index(2004-2006) in Mongolia in 1992 to that in 1997?
Offer a terse response. 1.03. What is the ratio of the Production index(2004-2006) of Lower middle income in 1992 to that in 1998?
Offer a very short reply. 0.87. What is the ratio of the Production index(2004-2006) of Grenada in 1992 to that in 1998?
Ensure brevity in your answer.  1.15. What is the ratio of the Production index(2004-2006) in Indonesia in 1992 to that in 1998?
Offer a terse response. 0.91. What is the ratio of the Production index(2004-2006) in Mongolia in 1992 to that in 1998?
Ensure brevity in your answer.  0.92. What is the ratio of the Production index(2004-2006) of Lower middle income in 1993 to that in 1994?
Your answer should be compact. 0.99. What is the ratio of the Production index(2004-2006) of Grenada in 1993 to that in 1994?
Provide a short and direct response. 0.98. What is the ratio of the Production index(2004-2006) of Indonesia in 1993 to that in 1994?
Your answer should be very brief. 0.98. What is the ratio of the Production index(2004-2006) in Mongolia in 1993 to that in 1994?
Give a very brief answer. 1.05. What is the ratio of the Production index(2004-2006) of Grenada in 1993 to that in 1995?
Your response must be concise. 1.05. What is the ratio of the Production index(2004-2006) in Indonesia in 1993 to that in 1995?
Your answer should be very brief. 0.89. What is the ratio of the Production index(2004-2006) in Mongolia in 1993 to that in 1995?
Provide a succinct answer. 1. What is the ratio of the Production index(2004-2006) in Lower middle income in 1993 to that in 1996?
Offer a very short reply. 0.92. What is the ratio of the Production index(2004-2006) of Grenada in 1993 to that in 1996?
Offer a very short reply. 1.07. What is the ratio of the Production index(2004-2006) of Indonesia in 1993 to that in 1996?
Your answer should be compact. 0.89. What is the ratio of the Production index(2004-2006) of Mongolia in 1993 to that in 1996?
Keep it short and to the point. 0.87. What is the ratio of the Production index(2004-2006) of Lower middle income in 1993 to that in 1997?
Provide a short and direct response. 0.91. What is the ratio of the Production index(2004-2006) of Grenada in 1993 to that in 1997?
Keep it short and to the point. 1.12. What is the ratio of the Production index(2004-2006) in Indonesia in 1993 to that in 1997?
Keep it short and to the point. 0.92. What is the ratio of the Production index(2004-2006) of Mongolia in 1993 to that in 1997?
Make the answer very short. 0.91. What is the ratio of the Production index(2004-2006) of Lower middle income in 1993 to that in 1998?
Offer a terse response. 0.89. What is the ratio of the Production index(2004-2006) in Grenada in 1993 to that in 1998?
Your response must be concise. 1.19. What is the ratio of the Production index(2004-2006) of Indonesia in 1993 to that in 1998?
Provide a short and direct response. 0.93. What is the ratio of the Production index(2004-2006) of Mongolia in 1993 to that in 1998?
Your answer should be compact. 0.82. What is the ratio of the Production index(2004-2006) in Lower middle income in 1994 to that in 1995?
Ensure brevity in your answer.  0.97. What is the ratio of the Production index(2004-2006) of Grenada in 1994 to that in 1995?
Offer a very short reply. 1.07. What is the ratio of the Production index(2004-2006) of Indonesia in 1994 to that in 1995?
Your response must be concise. 0.91. What is the ratio of the Production index(2004-2006) of Mongolia in 1994 to that in 1995?
Offer a terse response. 0.95. What is the ratio of the Production index(2004-2006) of Lower middle income in 1994 to that in 1996?
Provide a short and direct response. 0.93. What is the ratio of the Production index(2004-2006) in Grenada in 1994 to that in 1996?
Provide a short and direct response. 1.1. What is the ratio of the Production index(2004-2006) in Indonesia in 1994 to that in 1996?
Offer a terse response. 0.91. What is the ratio of the Production index(2004-2006) of Mongolia in 1994 to that in 1996?
Offer a very short reply. 0.83. What is the ratio of the Production index(2004-2006) of Lower middle income in 1994 to that in 1997?
Ensure brevity in your answer.  0.92. What is the ratio of the Production index(2004-2006) in Grenada in 1994 to that in 1997?
Provide a succinct answer. 1.15. What is the ratio of the Production index(2004-2006) in Indonesia in 1994 to that in 1997?
Offer a terse response. 0.94. What is the ratio of the Production index(2004-2006) in Mongolia in 1994 to that in 1997?
Offer a very short reply. 0.86. What is the ratio of the Production index(2004-2006) of Lower middle income in 1994 to that in 1998?
Ensure brevity in your answer.  0.91. What is the ratio of the Production index(2004-2006) of Grenada in 1994 to that in 1998?
Make the answer very short. 1.22. What is the ratio of the Production index(2004-2006) of Indonesia in 1994 to that in 1998?
Provide a succinct answer. 0.94. What is the ratio of the Production index(2004-2006) of Mongolia in 1994 to that in 1998?
Keep it short and to the point. 0.78. What is the ratio of the Production index(2004-2006) in Lower middle income in 1995 to that in 1996?
Offer a terse response. 0.97. What is the ratio of the Production index(2004-2006) in Grenada in 1995 to that in 1996?
Provide a short and direct response. 1.02. What is the ratio of the Production index(2004-2006) of Mongolia in 1995 to that in 1996?
Provide a succinct answer. 0.87. What is the ratio of the Production index(2004-2006) of Lower middle income in 1995 to that in 1997?
Your answer should be compact. 0.96. What is the ratio of the Production index(2004-2006) of Grenada in 1995 to that in 1997?
Keep it short and to the point. 1.07. What is the ratio of the Production index(2004-2006) of Indonesia in 1995 to that in 1997?
Provide a short and direct response. 1.03. What is the ratio of the Production index(2004-2006) in Mongolia in 1995 to that in 1997?
Your response must be concise. 0.91. What is the ratio of the Production index(2004-2006) of Lower middle income in 1995 to that in 1998?
Ensure brevity in your answer.  0.94. What is the ratio of the Production index(2004-2006) of Grenada in 1995 to that in 1998?
Provide a succinct answer. 1.13. What is the ratio of the Production index(2004-2006) of Indonesia in 1995 to that in 1998?
Your answer should be compact. 1.04. What is the ratio of the Production index(2004-2006) in Mongolia in 1995 to that in 1998?
Provide a short and direct response. 0.82. What is the ratio of the Production index(2004-2006) in Lower middle income in 1996 to that in 1997?
Offer a very short reply. 0.99. What is the ratio of the Production index(2004-2006) in Grenada in 1996 to that in 1997?
Ensure brevity in your answer.  1.05. What is the ratio of the Production index(2004-2006) in Indonesia in 1996 to that in 1997?
Your answer should be very brief. 1.04. What is the ratio of the Production index(2004-2006) in Mongolia in 1996 to that in 1997?
Your answer should be very brief. 1.04. What is the ratio of the Production index(2004-2006) of Lower middle income in 1996 to that in 1998?
Ensure brevity in your answer.  0.97. What is the ratio of the Production index(2004-2006) of Grenada in 1996 to that in 1998?
Give a very brief answer. 1.11. What is the ratio of the Production index(2004-2006) of Indonesia in 1996 to that in 1998?
Keep it short and to the point. 1.04. What is the ratio of the Production index(2004-2006) in Mongolia in 1996 to that in 1998?
Give a very brief answer. 0.94. What is the ratio of the Production index(2004-2006) of Lower middle income in 1997 to that in 1998?
Provide a succinct answer. 0.98. What is the ratio of the Production index(2004-2006) of Grenada in 1997 to that in 1998?
Provide a succinct answer. 1.06. What is the ratio of the Production index(2004-2006) in Indonesia in 1997 to that in 1998?
Your answer should be very brief. 1. What is the ratio of the Production index(2004-2006) in Mongolia in 1997 to that in 1998?
Offer a terse response. 0.9. What is the difference between the highest and the second highest Production index(2004-2006) in Lower middle income?
Keep it short and to the point. 1.6. What is the difference between the highest and the second highest Production index(2004-2006) of Grenada?
Offer a terse response. 3.11. What is the difference between the highest and the second highest Production index(2004-2006) in Indonesia?
Provide a short and direct response. 0.27. What is the difference between the highest and the second highest Production index(2004-2006) of Mongolia?
Give a very brief answer. 8.21. What is the difference between the highest and the lowest Production index(2004-2006) in Lower middle income?
Offer a very short reply. 16.58. What is the difference between the highest and the lowest Production index(2004-2006) of Grenada?
Ensure brevity in your answer.  25.44. What is the difference between the highest and the lowest Production index(2004-2006) of Indonesia?
Offer a terse response. 14.94. What is the difference between the highest and the lowest Production index(2004-2006) in Mongolia?
Provide a succinct answer. 38.74. 